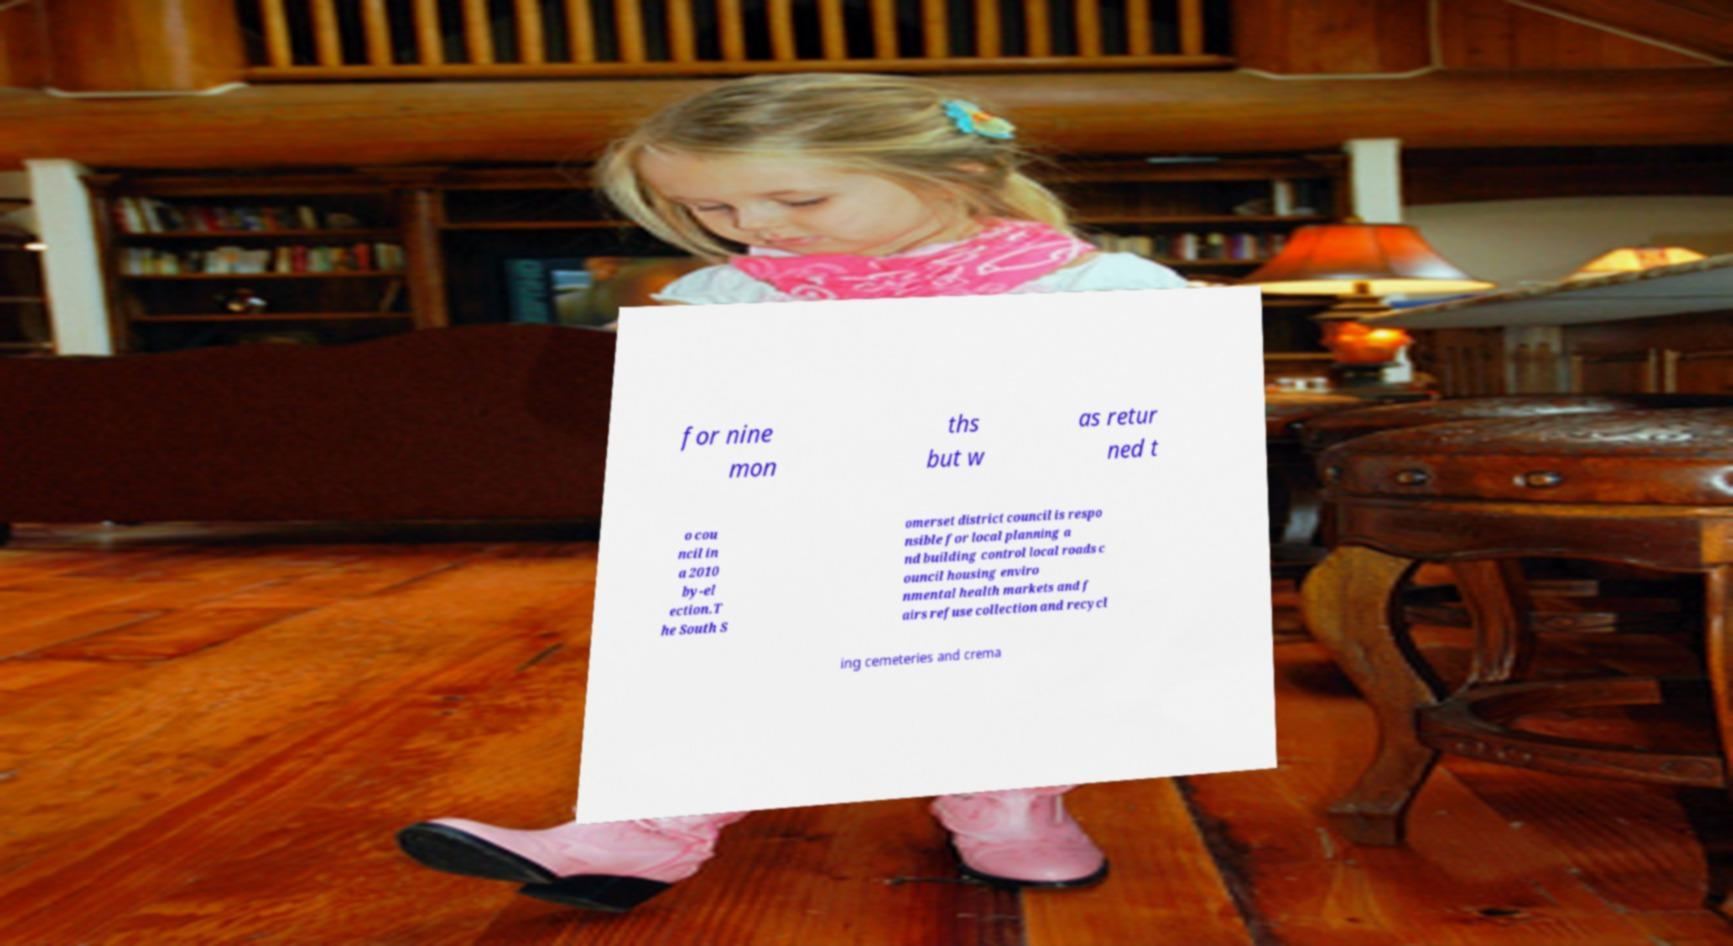Please read and relay the text visible in this image. What does it say? for nine mon ths but w as retur ned t o cou ncil in a 2010 by-el ection.T he South S omerset district council is respo nsible for local planning a nd building control local roads c ouncil housing enviro nmental health markets and f airs refuse collection and recycl ing cemeteries and crema 